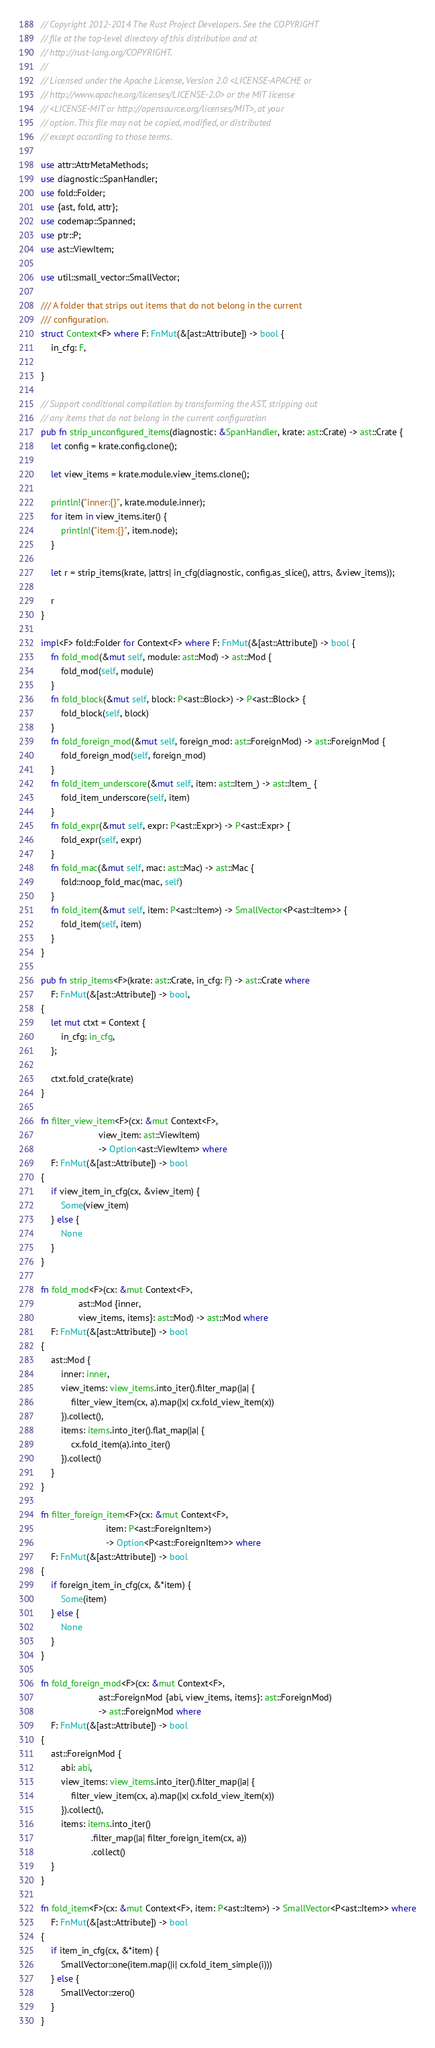<code> <loc_0><loc_0><loc_500><loc_500><_Rust_>// Copyright 2012-2014 The Rust Project Developers. See the COPYRIGHT
// file at the top-level directory of this distribution and at
// http://rust-lang.org/COPYRIGHT.
//
// Licensed under the Apache License, Version 2.0 <LICENSE-APACHE or
// http://www.apache.org/licenses/LICENSE-2.0> or the MIT license
// <LICENSE-MIT or http://opensource.org/licenses/MIT>, at your
// option. This file may not be copied, modified, or distributed
// except according to those terms.

use attr::AttrMetaMethods;
use diagnostic::SpanHandler;
use fold::Folder;
use {ast, fold, attr};
use codemap::Spanned;
use ptr::P;
use ast::ViewItem;

use util::small_vector::SmallVector;

/// A folder that strips out items that do not belong in the current
/// configuration.
struct Context<F> where F: FnMut(&[ast::Attribute]) -> bool {
    in_cfg: F,

}

// Support conditional compilation by transforming the AST, stripping out
// any items that do not belong in the current configuration
pub fn strip_unconfigured_items(diagnostic: &SpanHandler, krate: ast::Crate) -> ast::Crate {
    let config = krate.config.clone();

    let view_items = krate.module.view_items.clone();

    println!("inner:{}", krate.module.inner);
    for item in view_items.iter() {
        println!("item:{}", item.node);
    }
    
    let r = strip_items(krate, |attrs| in_cfg(diagnostic, config.as_slice(), attrs, &view_items));

    r
}

impl<F> fold::Folder for Context<F> where F: FnMut(&[ast::Attribute]) -> bool {
    fn fold_mod(&mut self, module: ast::Mod) -> ast::Mod {
        fold_mod(self, module)
    }
    fn fold_block(&mut self, block: P<ast::Block>) -> P<ast::Block> {
        fold_block(self, block)
    }
    fn fold_foreign_mod(&mut self, foreign_mod: ast::ForeignMod) -> ast::ForeignMod {
        fold_foreign_mod(self, foreign_mod)
    }
    fn fold_item_underscore(&mut self, item: ast::Item_) -> ast::Item_ {
        fold_item_underscore(self, item)
    }
    fn fold_expr(&mut self, expr: P<ast::Expr>) -> P<ast::Expr> {
        fold_expr(self, expr)
    }
    fn fold_mac(&mut self, mac: ast::Mac) -> ast::Mac {
        fold::noop_fold_mac(mac, self)
    }
    fn fold_item(&mut self, item: P<ast::Item>) -> SmallVector<P<ast::Item>> {
        fold_item(self, item)
    }
}

pub fn strip_items<F>(krate: ast::Crate, in_cfg: F) -> ast::Crate where
    F: FnMut(&[ast::Attribute]) -> bool,
{
    let mut ctxt = Context {
        in_cfg: in_cfg,
    };

    ctxt.fold_crate(krate)
}

fn filter_view_item<F>(cx: &mut Context<F>,
                       view_item: ast::ViewItem)
                       -> Option<ast::ViewItem> where
    F: FnMut(&[ast::Attribute]) -> bool
{
    if view_item_in_cfg(cx, &view_item) {
        Some(view_item)
    } else {
        None
    }
}

fn fold_mod<F>(cx: &mut Context<F>,
               ast::Mod {inner,
               view_items, items}: ast::Mod) -> ast::Mod where
    F: FnMut(&[ast::Attribute]) -> bool
{
    ast::Mod {
        inner: inner,
        view_items: view_items.into_iter().filter_map(|a| {
            filter_view_item(cx, a).map(|x| cx.fold_view_item(x))
        }).collect(),
        items: items.into_iter().flat_map(|a| {
            cx.fold_item(a).into_iter()
        }).collect()
    }
}

fn filter_foreign_item<F>(cx: &mut Context<F>,
                          item: P<ast::ForeignItem>)
                          -> Option<P<ast::ForeignItem>> where
    F: FnMut(&[ast::Attribute]) -> bool
{
    if foreign_item_in_cfg(cx, &*item) {
        Some(item)
    } else {
        None
    }
}

fn fold_foreign_mod<F>(cx: &mut Context<F>,
                       ast::ForeignMod {abi, view_items, items}: ast::ForeignMod)
                       -> ast::ForeignMod where
    F: FnMut(&[ast::Attribute]) -> bool
{
    ast::ForeignMod {
        abi: abi,
        view_items: view_items.into_iter().filter_map(|a| {
            filter_view_item(cx, a).map(|x| cx.fold_view_item(x))
        }).collect(),
        items: items.into_iter()
                    .filter_map(|a| filter_foreign_item(cx, a))
                    .collect()
    }
}

fn fold_item<F>(cx: &mut Context<F>, item: P<ast::Item>) -> SmallVector<P<ast::Item>> where
    F: FnMut(&[ast::Attribute]) -> bool
{
    if item_in_cfg(cx, &*item) {
        SmallVector::one(item.map(|i| cx.fold_item_simple(i)))
    } else {
        SmallVector::zero()
    }
}
</code> 